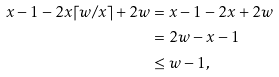Convert formula to latex. <formula><loc_0><loc_0><loc_500><loc_500>x - 1 - 2 x \lceil w / x \rceil + 2 w & = x - 1 - 2 x + 2 w \\ & = 2 w - x - 1 \\ & \leq w - 1 ,</formula> 